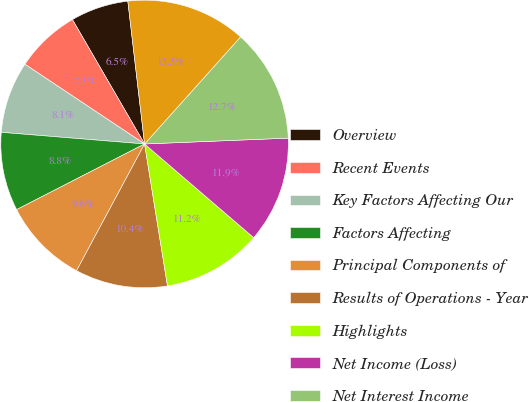Convert chart. <chart><loc_0><loc_0><loc_500><loc_500><pie_chart><fcel>Overview<fcel>Recent Events<fcel>Key Factors Affecting Our<fcel>Factors Affecting<fcel>Principal Components of<fcel>Results of Operations - Year<fcel>Highlights<fcel>Net Income (Loss)<fcel>Net Interest Income<fcel>Noninterest Income<nl><fcel>6.51%<fcel>7.28%<fcel>8.06%<fcel>8.84%<fcel>9.61%<fcel>10.39%<fcel>11.16%<fcel>11.94%<fcel>12.72%<fcel>13.49%<nl></chart> 